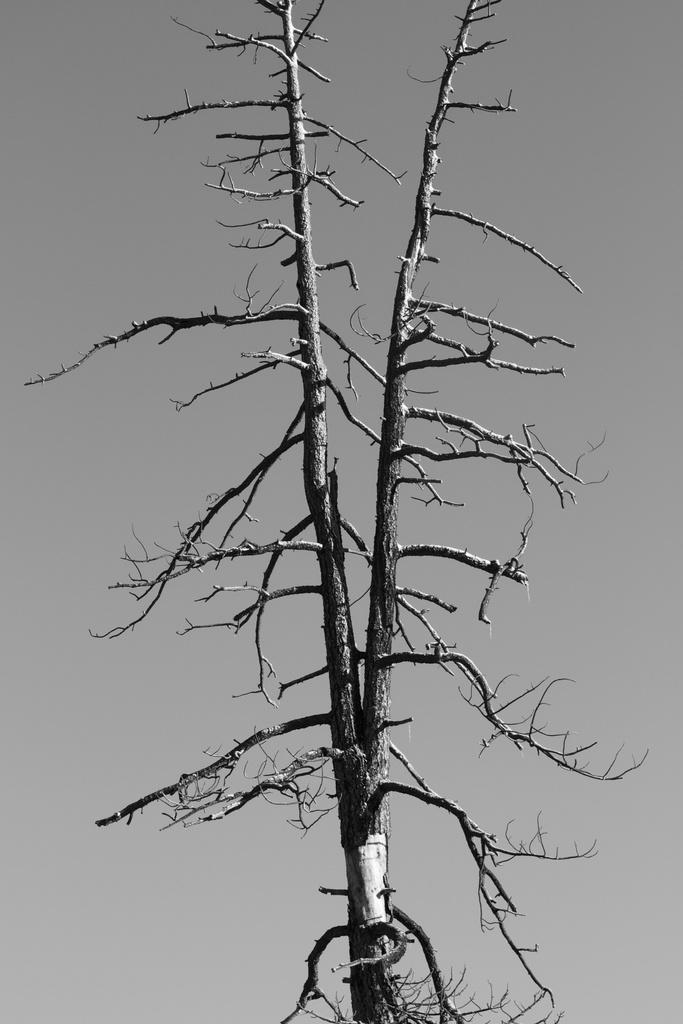What is the color scheme of the image? The image is black and white. What type of tree can be seen in the image? There is a dried tree in the image. What can be seen in the background of the image? The background of the image is visible. Where is the cannon being used in the image? There is no cannon present in the image. 